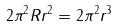<formula> <loc_0><loc_0><loc_500><loc_500>2 \pi ^ { 2 } R r ^ { 2 } = 2 \pi ^ { 2 } r ^ { 3 }</formula> 